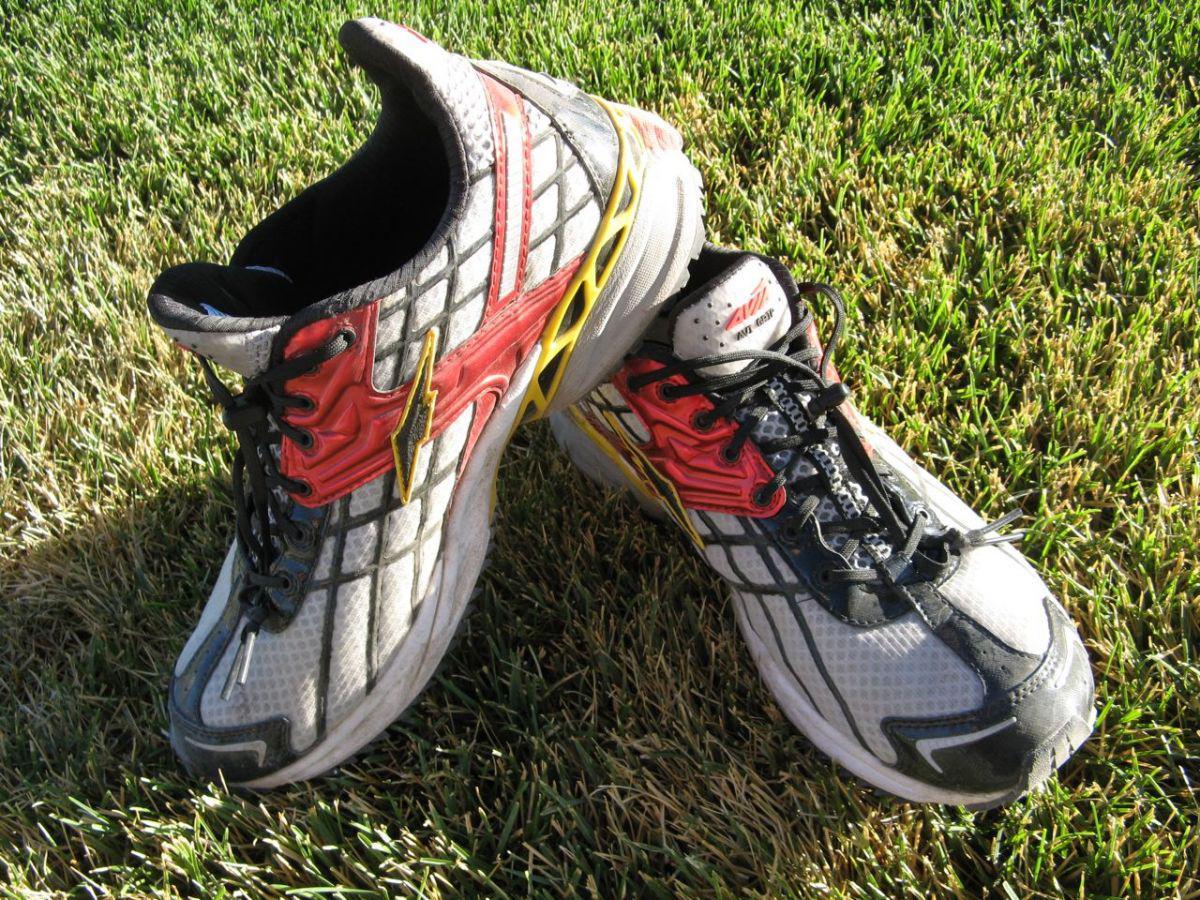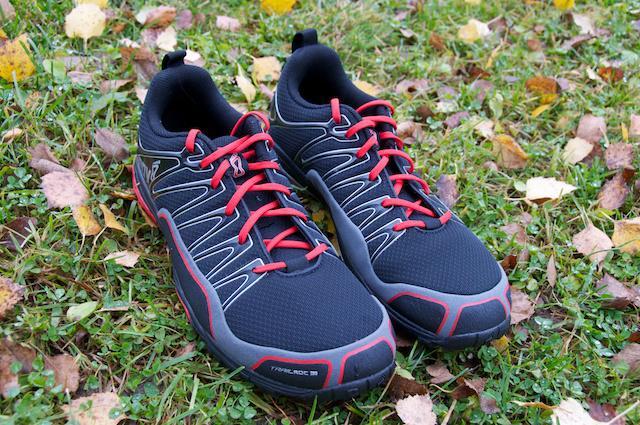The first image is the image on the left, the second image is the image on the right. Considering the images on both sides, is "there are at most2 pair of shoes per image pair" valid? Answer yes or no. Yes. The first image is the image on the left, the second image is the image on the right. Analyze the images presented: Is the assertion "There is a pair of athletic shoes sitting outside in the grass." valid? Answer yes or no. Yes. 